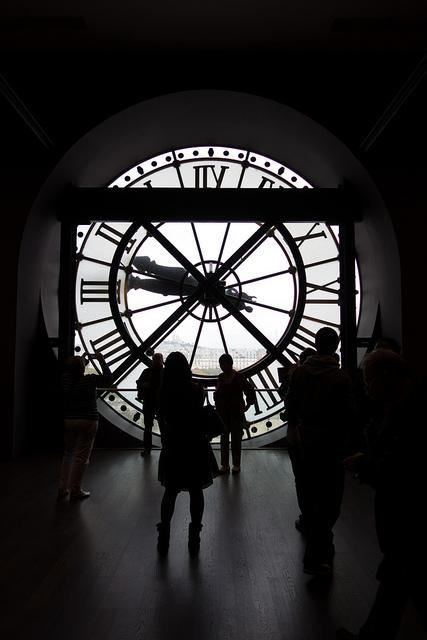What time is depicted in the photo? two fifteen 